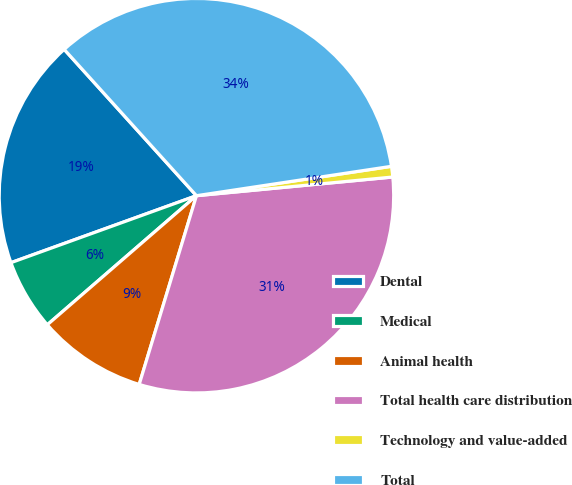Convert chart. <chart><loc_0><loc_0><loc_500><loc_500><pie_chart><fcel>Dental<fcel>Medical<fcel>Animal health<fcel>Total health care distribution<fcel>Technology and value-added<fcel>Total<nl><fcel>18.82%<fcel>5.84%<fcel>8.96%<fcel>31.2%<fcel>0.87%<fcel>34.32%<nl></chart> 